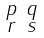Convert formula to latex. <formula><loc_0><loc_0><loc_500><loc_500>\begin{smallmatrix} p & q \\ r & s \end{smallmatrix}</formula> 